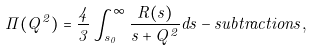Convert formula to latex. <formula><loc_0><loc_0><loc_500><loc_500>\Pi ( Q ^ { 2 } ) = \frac { 4 } { 3 } \int _ { s _ { 0 } } ^ { \infty } \frac { R ( s ) } { s + Q ^ { 2 } } d s - s u b t r a c t i o n s ,</formula> 